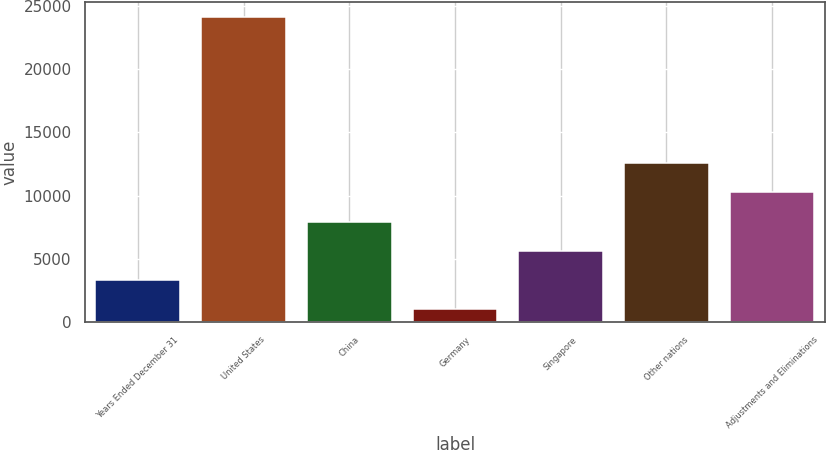Convert chart to OTSL. <chart><loc_0><loc_0><loc_500><loc_500><bar_chart><fcel>Years Ended December 31<fcel>United States<fcel>China<fcel>Germany<fcel>Singapore<fcel>Other nations<fcel>Adjustments and Eliminations<nl><fcel>3311<fcel>24128<fcel>7937<fcel>998<fcel>5624<fcel>12563<fcel>10250<nl></chart> 